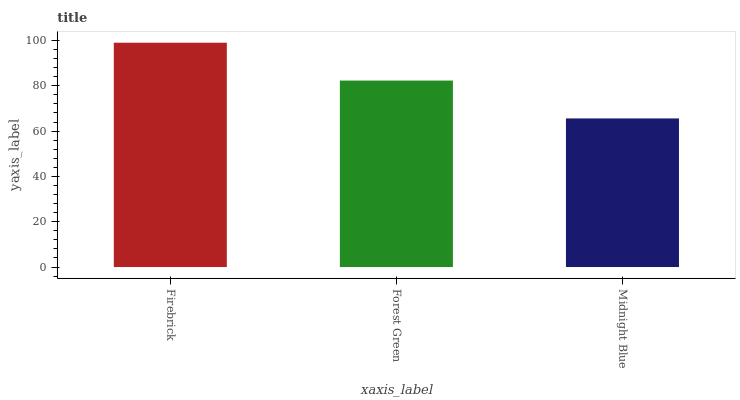Is Midnight Blue the minimum?
Answer yes or no. Yes. Is Firebrick the maximum?
Answer yes or no. Yes. Is Forest Green the minimum?
Answer yes or no. No. Is Forest Green the maximum?
Answer yes or no. No. Is Firebrick greater than Forest Green?
Answer yes or no. Yes. Is Forest Green less than Firebrick?
Answer yes or no. Yes. Is Forest Green greater than Firebrick?
Answer yes or no. No. Is Firebrick less than Forest Green?
Answer yes or no. No. Is Forest Green the high median?
Answer yes or no. Yes. Is Forest Green the low median?
Answer yes or no. Yes. Is Firebrick the high median?
Answer yes or no. No. Is Firebrick the low median?
Answer yes or no. No. 